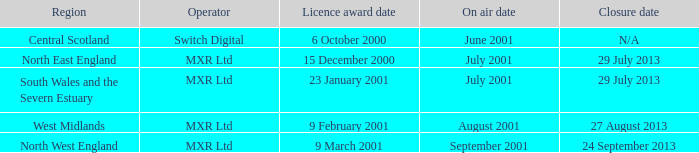What is the authorization award date for north east england? 15 December 2000. 